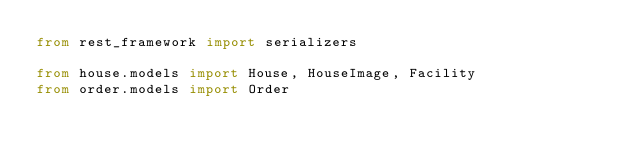<code> <loc_0><loc_0><loc_500><loc_500><_Python_>from rest_framework import serializers

from house.models import House, HouseImage, Facility
from order.models import Order

</code> 